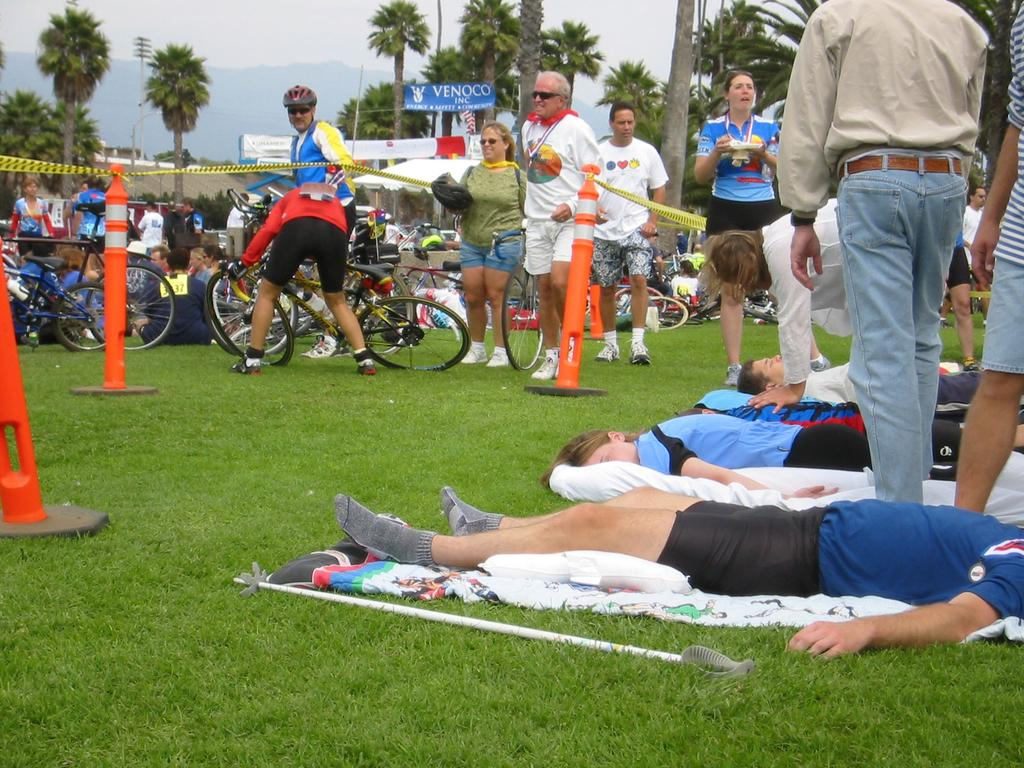What type of vegetation is present in the image? There is grass in the image. Who or what can be seen in the image besides the grass? There is a group of people and bicycles in the image. What else is visible in the image? There are trees and banners in the image. What is visible at the top of the image? The sky is visible at the top of the image. Can you tell me which actor is performing on the wall in the image? There is no actor performing on a wall in the image; the image does not contain any walls or actors. 